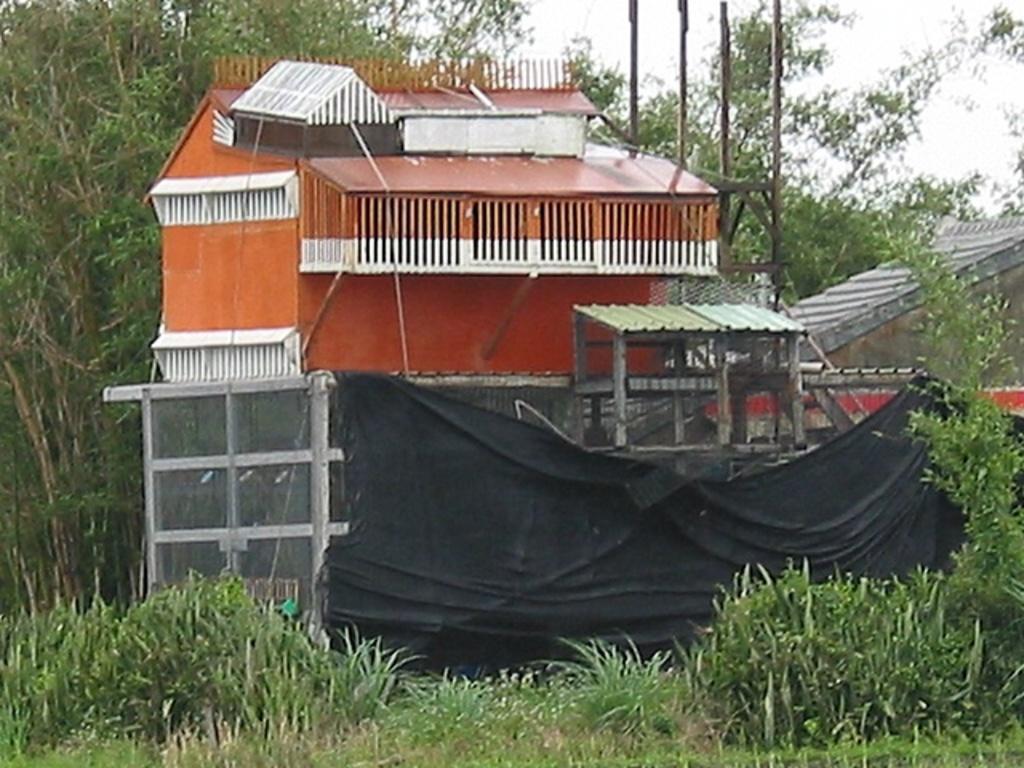In one or two sentences, can you explain what this image depicts? At the bottom of the image I can see the grass. In the background, I can see groups of trees. In the middle of the image I can see the house. 